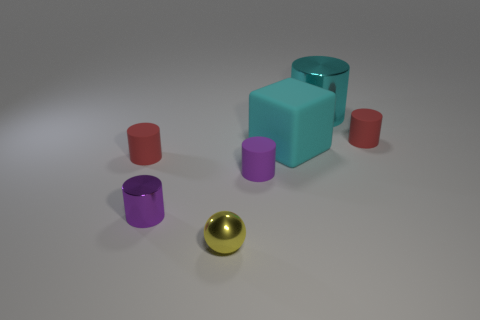Subtract all cyan cylinders. How many cylinders are left? 4 Subtract all tiny purple shiny cylinders. How many cylinders are left? 4 Subtract all green cylinders. Subtract all blue cubes. How many cylinders are left? 5 Add 3 spheres. How many objects exist? 10 Subtract all cubes. How many objects are left? 6 Add 2 metal balls. How many metal balls exist? 3 Subtract 0 green balls. How many objects are left? 7 Subtract all cyan rubber cubes. Subtract all cubes. How many objects are left? 5 Add 2 yellow objects. How many yellow objects are left? 3 